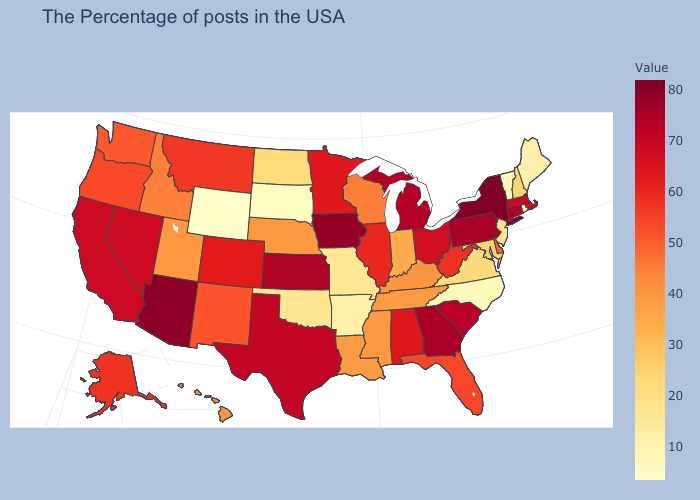Among the states that border Delaware , does New Jersey have the lowest value?
Concise answer only. Yes. Does North Carolina have the lowest value in the South?
Concise answer only. Yes. Among the states that border Illinois , does Iowa have the highest value?
Quick response, please. Yes. Among the states that border Iowa , does Minnesota have the highest value?
Short answer required. Yes. Does Wyoming have the lowest value in the West?
Concise answer only. Yes. Does North Dakota have a lower value than North Carolina?
Keep it brief. No. 